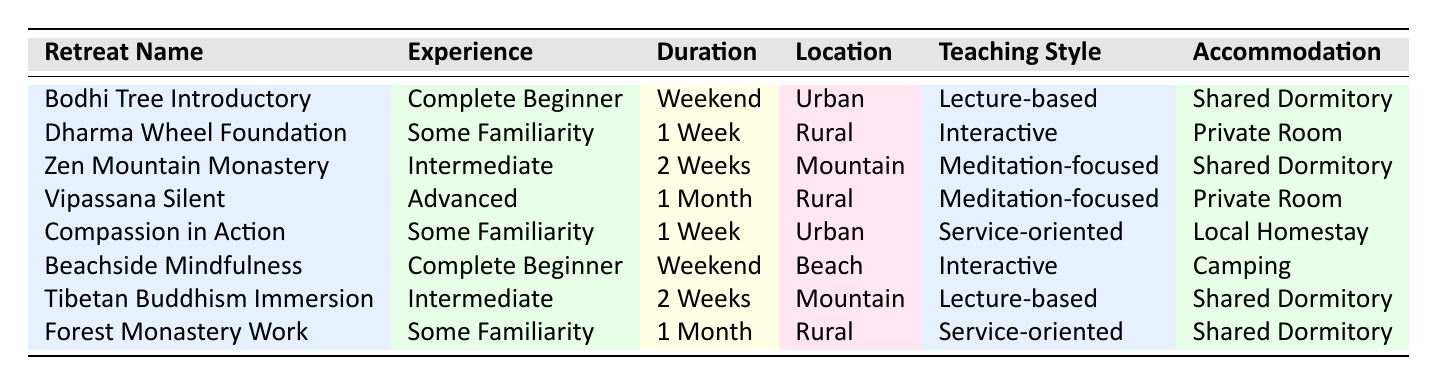What is the location of the Bodhi Tree Introductory Retreat? The Bodhi Tree Introductory Retreat is listed under the "Location" column of the table, which indicates that its location is Urban.
Answer: Urban How many retreats are available for Complete Beginners? There are two retreats listed for Complete Beginners: the Bodhi Tree Introductory and the Beachside Mindfulness.
Answer: 2 Which retreat offers a Private Room accommodation and is located in a Rural area? The Vipassana Silent Retreat is the only retreat that offers Private Room accommodation and is located in a Rural area, according to the specific characteristics listed.
Answer: Vipassana Silent Retreat Are there any retreats with a Meditation-focused teaching style that are available for Intermediate or Advanced participants? Yes, the Zen Mountain Monastery Intensive is available for Intermediate participants, and the Vipassana Silent Retreat is for Advanced participants, both of which have a Meditation-focused teaching style.
Answer: Yes What is the average duration of all retreats that are for Intermediate participants? The Intermediate retreats listed are the Zen Mountain Monastery Intensive and the Tibetan Buddhism Immersion, both of which have a duration of 2 Weeks. The average duration can be computed as (2 + 2) / 2 = 2 Weeks.
Answer: 2 Weeks Which retreat is the only one with a Service-oriented teaching style held for a duration of 1 Month? The Forest Monastery Work Retreat is the only retreat that has a Service-oriented teaching style and lasts for 1 Month.
Answer: Forest Monastery Work Retreat Is there a retreat located at a Beach with an Interactive teaching style? Yes, the Beachside Mindfulness Weekend is located at a Beach and has an Interactive teaching style.
Answer: Yes What type of accommodation is provided for retreats focused on Meditation for Advanced participants? The Vipassana Silent Retreat offers a Private Room for Advanced participants with a Meditation-focused teaching style, as indicated in the table.
Answer: Private Room 